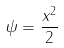Convert formula to latex. <formula><loc_0><loc_0><loc_500><loc_500>\psi = \frac { x ^ { 2 } } { 2 }</formula> 